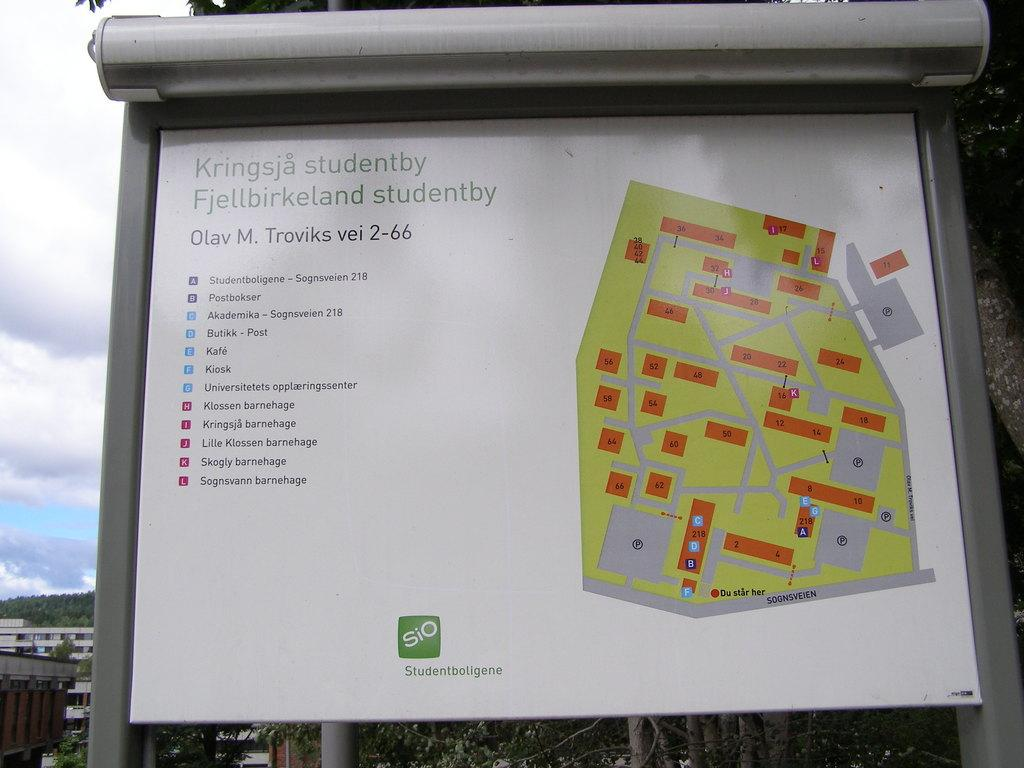<image>
Offer a succinct explanation of the picture presented. A map of a foreign language park reading Kringsja studentby Fjellbirkeland studentby. 